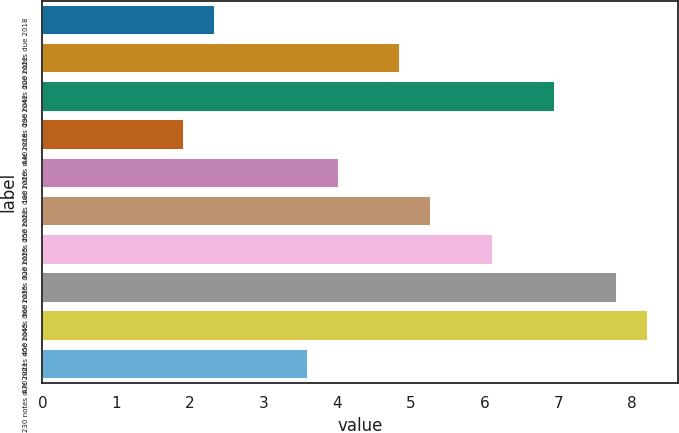Convert chart to OTSL. <chart><loc_0><loc_0><loc_500><loc_500><bar_chart><fcel>200 notes due 2018<fcel>290 notes due 2022<fcel>440 notes due 2042<fcel>180 notes due 2018<fcel>250 notes due 2020<fcel>320 notes due 2022<fcel>360 notes due 2025<fcel>450 notes due 2035<fcel>470 notes due 2045<fcel>230 notes due 2021<nl><fcel>2.34<fcel>4.86<fcel>6.96<fcel>1.92<fcel>4.02<fcel>5.28<fcel>6.12<fcel>7.8<fcel>8.22<fcel>3.6<nl></chart> 